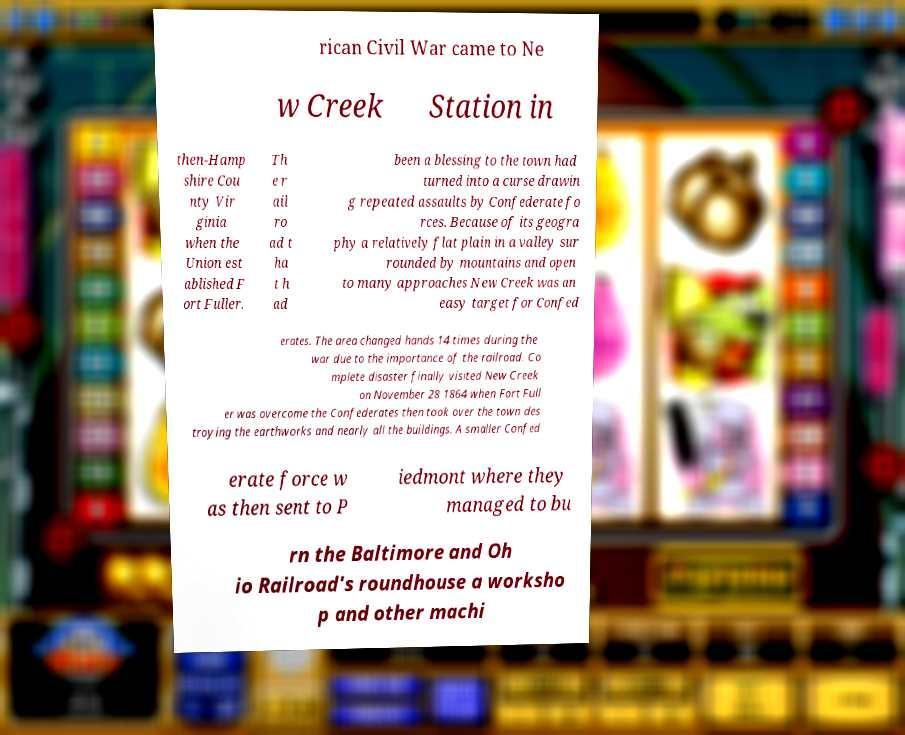I need the written content from this picture converted into text. Can you do that? rican Civil War came to Ne w Creek Station in then-Hamp shire Cou nty Vir ginia when the Union est ablished F ort Fuller. Th e r ail ro ad t ha t h ad been a blessing to the town had turned into a curse drawin g repeated assaults by Confederate fo rces. Because of its geogra phy a relatively flat plain in a valley sur rounded by mountains and open to many approaches New Creek was an easy target for Confed erates. The area changed hands 14 times during the war due to the importance of the railroad. Co mplete disaster finally visited New Creek on November 28 1864 when Fort Full er was overcome the Confederates then took over the town des troying the earthworks and nearly all the buildings. A smaller Confed erate force w as then sent to P iedmont where they managed to bu rn the Baltimore and Oh io Railroad's roundhouse a worksho p and other machi 